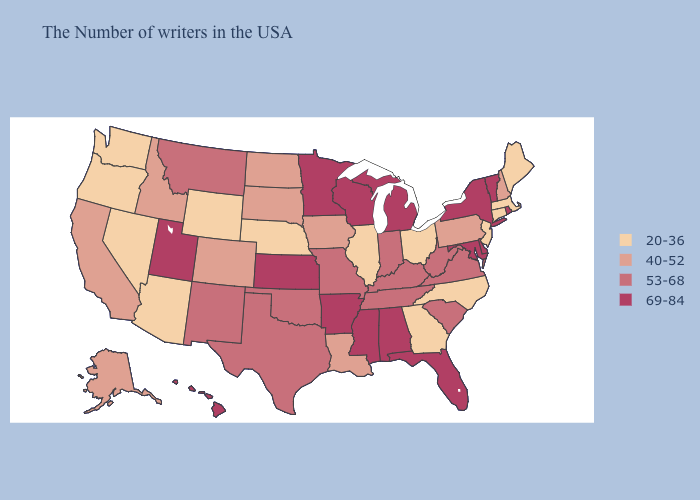Does New Hampshire have the same value as Alaska?
Keep it brief. Yes. What is the value of North Dakota?
Concise answer only. 40-52. Does Kentucky have a higher value than Nebraska?
Short answer required. Yes. What is the lowest value in states that border Minnesota?
Keep it brief. 40-52. What is the highest value in states that border Virginia?
Answer briefly. 69-84. Among the states that border Pennsylvania , does Maryland have the lowest value?
Quick response, please. No. Name the states that have a value in the range 69-84?
Be succinct. Rhode Island, Vermont, New York, Delaware, Maryland, Florida, Michigan, Alabama, Wisconsin, Mississippi, Arkansas, Minnesota, Kansas, Utah, Hawaii. Does Vermont have a lower value than Florida?
Give a very brief answer. No. What is the value of Delaware?
Keep it brief. 69-84. Name the states that have a value in the range 40-52?
Keep it brief. New Hampshire, Pennsylvania, Louisiana, Iowa, South Dakota, North Dakota, Colorado, Idaho, California, Alaska. What is the value of New York?
Quick response, please. 69-84. What is the value of Tennessee?
Be succinct. 53-68. What is the highest value in the West ?
Be succinct. 69-84. 